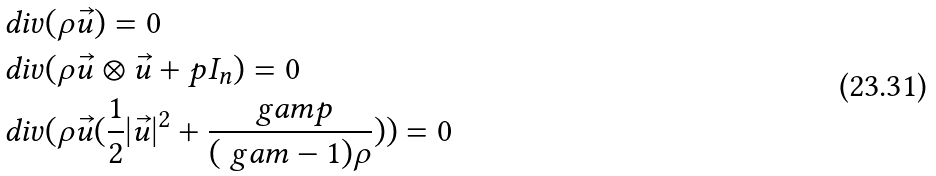<formula> <loc_0><loc_0><loc_500><loc_500>& d i v ( \rho \vec { u } ) = 0 \\ & d i v ( \rho \vec { u } \otimes \vec { u } + p I _ { n } ) = 0 \\ & d i v ( \rho \vec { u } ( \frac { 1 } { 2 } | \vec { u } | ^ { 2 } + \frac { \ g a m p } { ( \ g a m - 1 ) \rho } ) ) = 0</formula> 